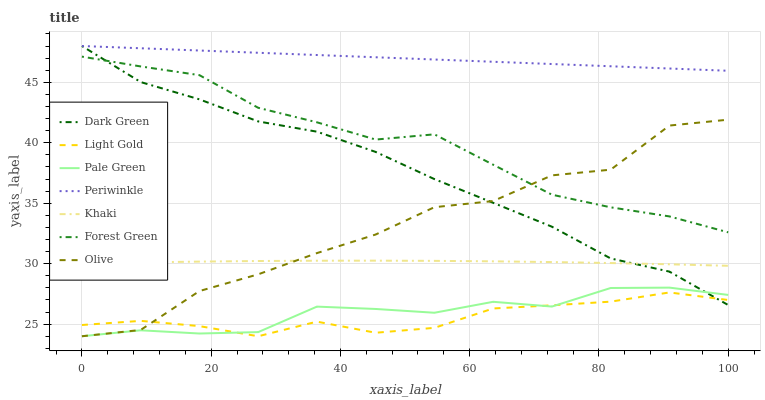Does Light Gold have the minimum area under the curve?
Answer yes or no. Yes. Does Periwinkle have the maximum area under the curve?
Answer yes or no. Yes. Does Forest Green have the minimum area under the curve?
Answer yes or no. No. Does Forest Green have the maximum area under the curve?
Answer yes or no. No. Is Periwinkle the smoothest?
Answer yes or no. Yes. Is Olive the roughest?
Answer yes or no. Yes. Is Forest Green the smoothest?
Answer yes or no. No. Is Forest Green the roughest?
Answer yes or no. No. Does Pale Green have the lowest value?
Answer yes or no. Yes. Does Forest Green have the lowest value?
Answer yes or no. No. Does Dark Green have the highest value?
Answer yes or no. Yes. Does Forest Green have the highest value?
Answer yes or no. No. Is Olive less than Periwinkle?
Answer yes or no. Yes. Is Periwinkle greater than Khaki?
Answer yes or no. Yes. Does Olive intersect Forest Green?
Answer yes or no. Yes. Is Olive less than Forest Green?
Answer yes or no. No. Is Olive greater than Forest Green?
Answer yes or no. No. Does Olive intersect Periwinkle?
Answer yes or no. No. 